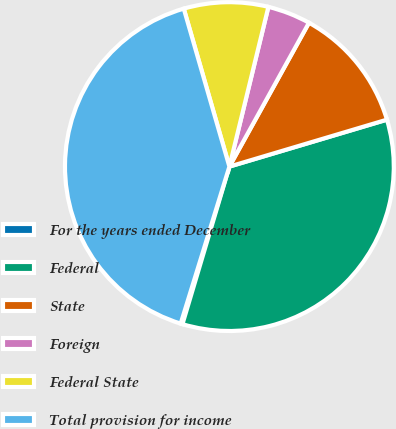Convert chart. <chart><loc_0><loc_0><loc_500><loc_500><pie_chart><fcel>For the years ended December<fcel>Federal<fcel>State<fcel>Foreign<fcel>Federal State<fcel>Total provision for income<nl><fcel>0.18%<fcel>34.22%<fcel>12.35%<fcel>4.23%<fcel>8.29%<fcel>40.74%<nl></chart> 